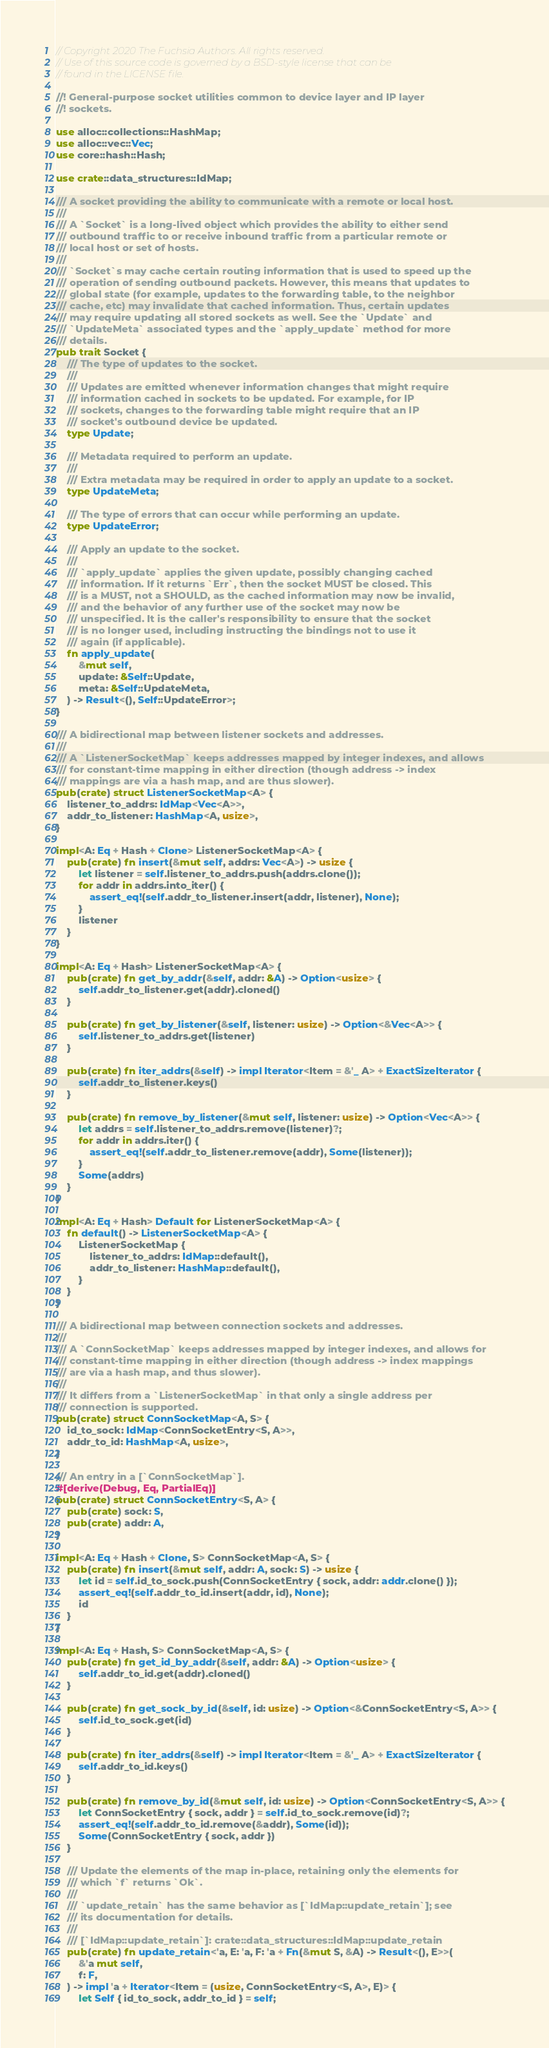Convert code to text. <code><loc_0><loc_0><loc_500><loc_500><_Rust_>// Copyright 2020 The Fuchsia Authors. All rights reserved.
// Use of this source code is governed by a BSD-style license that can be
// found in the LICENSE file.

//! General-purpose socket utilities common to device layer and IP layer
//! sockets.

use alloc::collections::HashMap;
use alloc::vec::Vec;
use core::hash::Hash;

use crate::data_structures::IdMap;

/// A socket providing the ability to communicate with a remote or local host.
///
/// A `Socket` is a long-lived object which provides the ability to either send
/// outbound traffic to or receive inbound traffic from a particular remote or
/// local host or set of hosts.
///
/// `Socket`s may cache certain routing information that is used to speed up the
/// operation of sending outbound packets. However, this means that updates to
/// global state (for example, updates to the forwarding table, to the neighbor
/// cache, etc) may invalidate that cached information. Thus, certain updates
/// may require updating all stored sockets as well. See the `Update` and
/// `UpdateMeta` associated types and the `apply_update` method for more
/// details.
pub trait Socket {
    /// The type of updates to the socket.
    ///
    /// Updates are emitted whenever information changes that might require
    /// information cached in sockets to be updated. For example, for IP
    /// sockets, changes to the forwarding table might require that an IP
    /// socket's outbound device be updated.
    type Update;

    /// Metadata required to perform an update.
    ///
    /// Extra metadata may be required in order to apply an update to a socket.
    type UpdateMeta;

    /// The type of errors that can occur while performing an update.
    type UpdateError;

    /// Apply an update to the socket.
    ///
    /// `apply_update` applies the given update, possibly changing cached
    /// information. If it returns `Err`, then the socket MUST be closed. This
    /// is a MUST, not a SHOULD, as the cached information may now be invalid,
    /// and the behavior of any further use of the socket may now be
    /// unspecified. It is the caller's responsibility to ensure that the socket
    /// is no longer used, including instructing the bindings not to use it
    /// again (if applicable).
    fn apply_update(
        &mut self,
        update: &Self::Update,
        meta: &Self::UpdateMeta,
    ) -> Result<(), Self::UpdateError>;
}

/// A bidirectional map between listener sockets and addresses.
///
/// A `ListenerSocketMap` keeps addresses mapped by integer indexes, and allows
/// for constant-time mapping in either direction (though address -> index
/// mappings are via a hash map, and are thus slower).
pub(crate) struct ListenerSocketMap<A> {
    listener_to_addrs: IdMap<Vec<A>>,
    addr_to_listener: HashMap<A, usize>,
}

impl<A: Eq + Hash + Clone> ListenerSocketMap<A> {
    pub(crate) fn insert(&mut self, addrs: Vec<A>) -> usize {
        let listener = self.listener_to_addrs.push(addrs.clone());
        for addr in addrs.into_iter() {
            assert_eq!(self.addr_to_listener.insert(addr, listener), None);
        }
        listener
    }
}

impl<A: Eq + Hash> ListenerSocketMap<A> {
    pub(crate) fn get_by_addr(&self, addr: &A) -> Option<usize> {
        self.addr_to_listener.get(addr).cloned()
    }

    pub(crate) fn get_by_listener(&self, listener: usize) -> Option<&Vec<A>> {
        self.listener_to_addrs.get(listener)
    }

    pub(crate) fn iter_addrs(&self) -> impl Iterator<Item = &'_ A> + ExactSizeIterator {
        self.addr_to_listener.keys()
    }

    pub(crate) fn remove_by_listener(&mut self, listener: usize) -> Option<Vec<A>> {
        let addrs = self.listener_to_addrs.remove(listener)?;
        for addr in addrs.iter() {
            assert_eq!(self.addr_to_listener.remove(addr), Some(listener));
        }
        Some(addrs)
    }
}

impl<A: Eq + Hash> Default for ListenerSocketMap<A> {
    fn default() -> ListenerSocketMap<A> {
        ListenerSocketMap {
            listener_to_addrs: IdMap::default(),
            addr_to_listener: HashMap::default(),
        }
    }
}

/// A bidirectional map between connection sockets and addresses.
///
/// A `ConnSocketMap` keeps addresses mapped by integer indexes, and allows for
/// constant-time mapping in either direction (though address -> index mappings
/// are via a hash map, and thus slower).
///
/// It differs from a `ListenerSocketMap` in that only a single address per
/// connection is supported.
pub(crate) struct ConnSocketMap<A, S> {
    id_to_sock: IdMap<ConnSocketEntry<S, A>>,
    addr_to_id: HashMap<A, usize>,
}

/// An entry in a [`ConnSocketMap`].
#[derive(Debug, Eq, PartialEq)]
pub(crate) struct ConnSocketEntry<S, A> {
    pub(crate) sock: S,
    pub(crate) addr: A,
}

impl<A: Eq + Hash + Clone, S> ConnSocketMap<A, S> {
    pub(crate) fn insert(&mut self, addr: A, sock: S) -> usize {
        let id = self.id_to_sock.push(ConnSocketEntry { sock, addr: addr.clone() });
        assert_eq!(self.addr_to_id.insert(addr, id), None);
        id
    }
}

impl<A: Eq + Hash, S> ConnSocketMap<A, S> {
    pub(crate) fn get_id_by_addr(&self, addr: &A) -> Option<usize> {
        self.addr_to_id.get(addr).cloned()
    }

    pub(crate) fn get_sock_by_id(&self, id: usize) -> Option<&ConnSocketEntry<S, A>> {
        self.id_to_sock.get(id)
    }

    pub(crate) fn iter_addrs(&self) -> impl Iterator<Item = &'_ A> + ExactSizeIterator {
        self.addr_to_id.keys()
    }

    pub(crate) fn remove_by_id(&mut self, id: usize) -> Option<ConnSocketEntry<S, A>> {
        let ConnSocketEntry { sock, addr } = self.id_to_sock.remove(id)?;
        assert_eq!(self.addr_to_id.remove(&addr), Some(id));
        Some(ConnSocketEntry { sock, addr })
    }

    /// Update the elements of the map in-place, retaining only the elements for
    /// which `f` returns `Ok`.
    ///
    /// `update_retain` has the same behavior as [`IdMap::update_retain`]; see
    /// its documentation for details.
    ///
    /// [`IdMap::update_retain`]: crate::data_structures::IdMap::update_retain
    pub(crate) fn update_retain<'a, E: 'a, F: 'a + Fn(&mut S, &A) -> Result<(), E>>(
        &'a mut self,
        f: F,
    ) -> impl 'a + Iterator<Item = (usize, ConnSocketEntry<S, A>, E)> {
        let Self { id_to_sock, addr_to_id } = self;</code> 